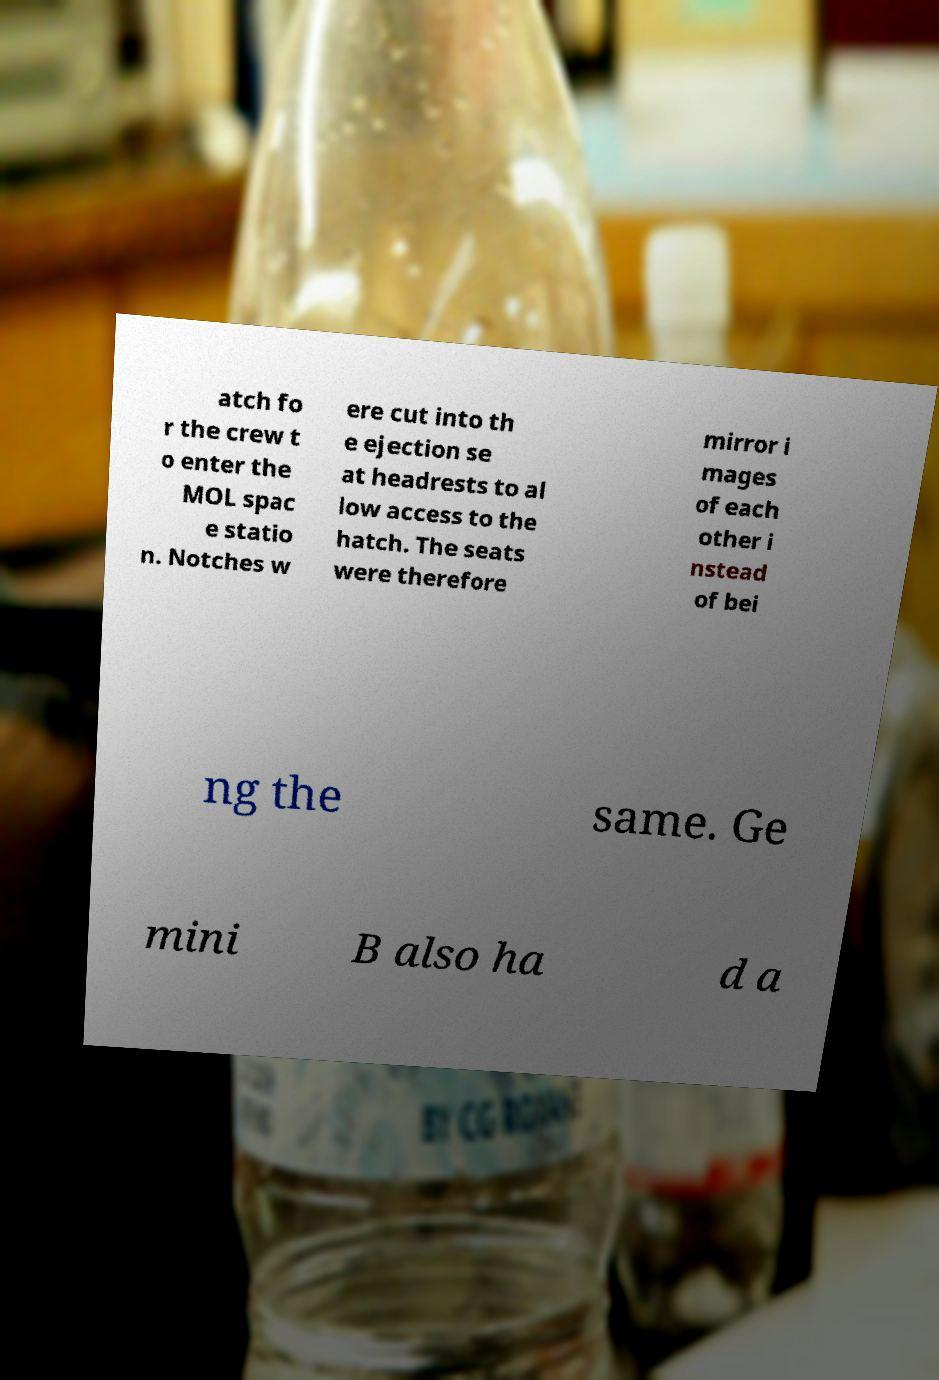Could you extract and type out the text from this image? atch fo r the crew t o enter the MOL spac e statio n. Notches w ere cut into th e ejection se at headrests to al low access to the hatch. The seats were therefore mirror i mages of each other i nstead of bei ng the same. Ge mini B also ha d a 